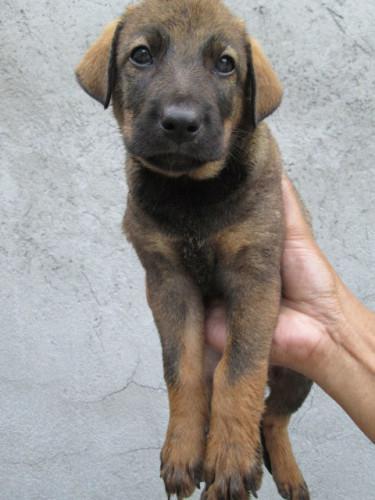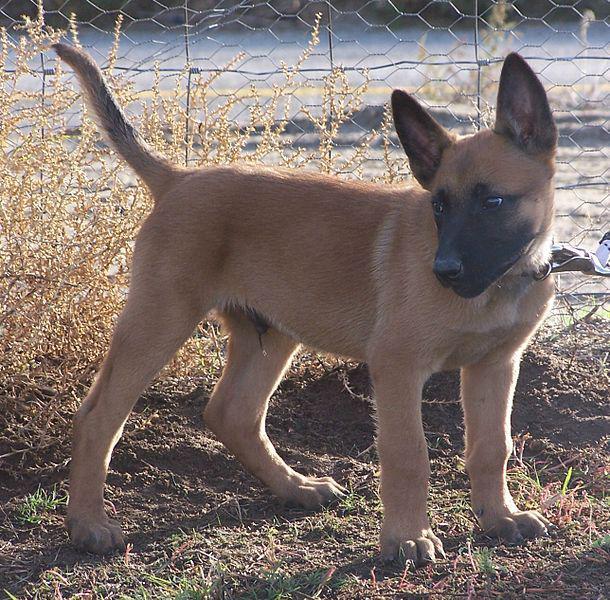The first image is the image on the left, the second image is the image on the right. Assess this claim about the two images: "None of the dogs has their mouths open.". Correct or not? Answer yes or no. Yes. The first image is the image on the left, the second image is the image on the right. For the images shown, is this caption "The dog in the right image is sitting upright, with head turned leftward." true? Answer yes or no. No. 